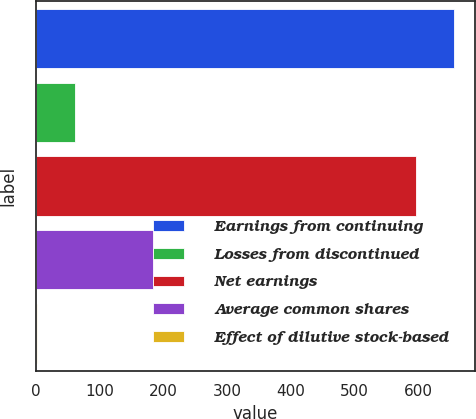Convert chart to OTSL. <chart><loc_0><loc_0><loc_500><loc_500><bar_chart><fcel>Earnings from continuing<fcel>Losses from discontinued<fcel>Net earnings<fcel>Average common shares<fcel>Effect of dilutive stock-based<nl><fcel>656.18<fcel>62.18<fcel>596<fcel>184.18<fcel>2<nl></chart> 